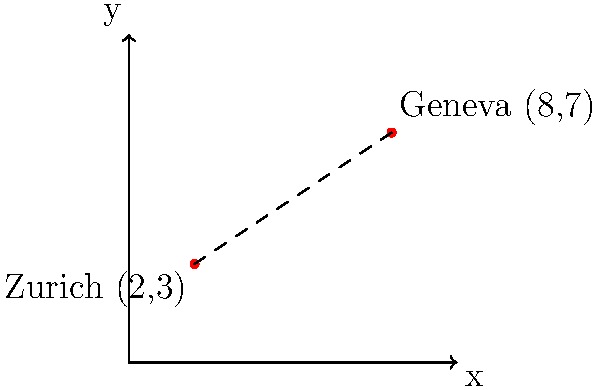As an economic development officer guiding a business professional through expanding their business in Switzerland, you need to calculate the distance between two major cities: Zurich and Geneva. On the coordinate plane representing a map of Switzerland, Zurich is located at (2,3) and Geneva at (8,7). Using the distance formula, calculate the straight-line distance between these two cities. Round your answer to two decimal places. To calculate the distance between two points on a coordinate plane, we use the distance formula:

$$d = \sqrt{(x_2 - x_1)^2 + (y_2 - y_1)^2}$$

Where $(x_1, y_1)$ represents the coordinates of the first point (Zurich) and $(x_2, y_2)$ represents the coordinates of the second point (Geneva).

Step 1: Identify the coordinates
Zurich: $(x_1, y_1) = (2, 3)$
Geneva: $(x_2, y_2) = (8, 7)$

Step 2: Plug the values into the distance formula
$$d = \sqrt{(8 - 2)^2 + (7 - 3)^2}$$

Step 3: Simplify the expressions inside the parentheses
$$d = \sqrt{6^2 + 4^2}$$

Step 4: Calculate the squares
$$d = \sqrt{36 + 16}$$

Step 5: Add the values under the square root
$$d = \sqrt{52}$$

Step 6: Calculate the square root and round to two decimal places
$$d \approx 7.21$$

Therefore, the straight-line distance between Zurich and Geneva on this coordinate plane is approximately 7.21 units.
Answer: 7.21 units 